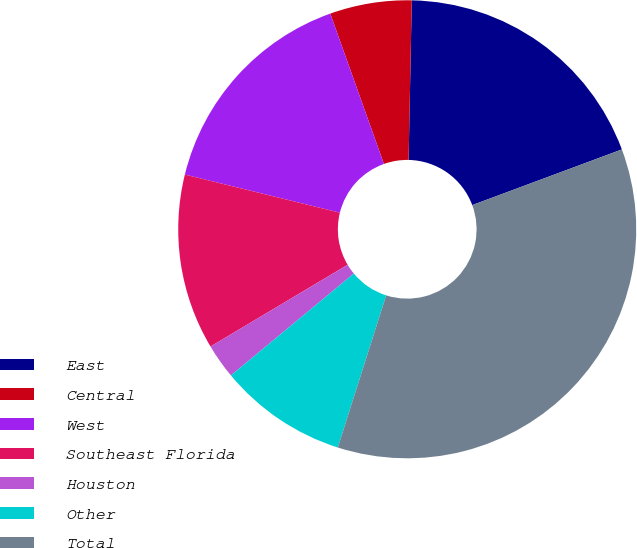<chart> <loc_0><loc_0><loc_500><loc_500><pie_chart><fcel>East<fcel>Central<fcel>West<fcel>Southeast Florida<fcel>Houston<fcel>Other<fcel>Total<nl><fcel>19.01%<fcel>5.77%<fcel>15.7%<fcel>12.39%<fcel>2.46%<fcel>9.08%<fcel>35.56%<nl></chart> 